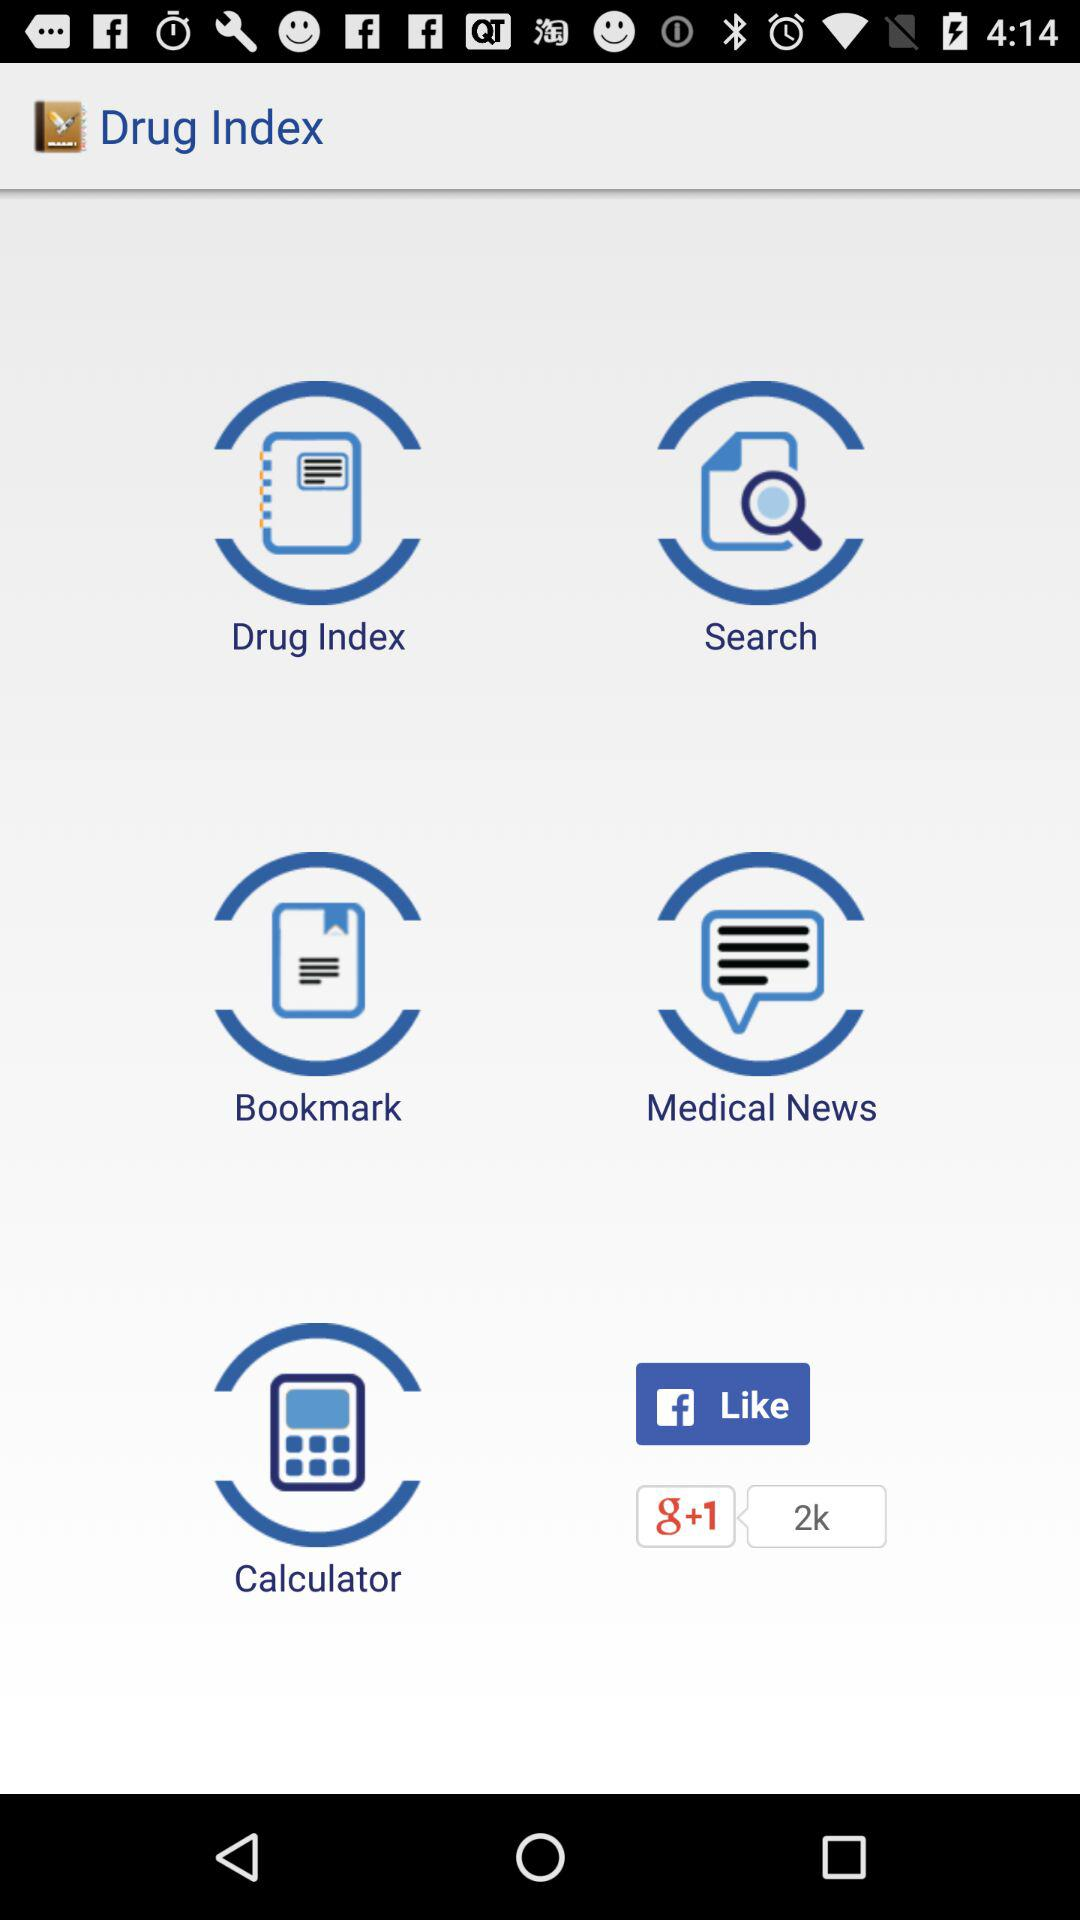What's the number of recommendations received for the application on "g+1"? The number of recommendations received for the application on "g+1" is 2000. 